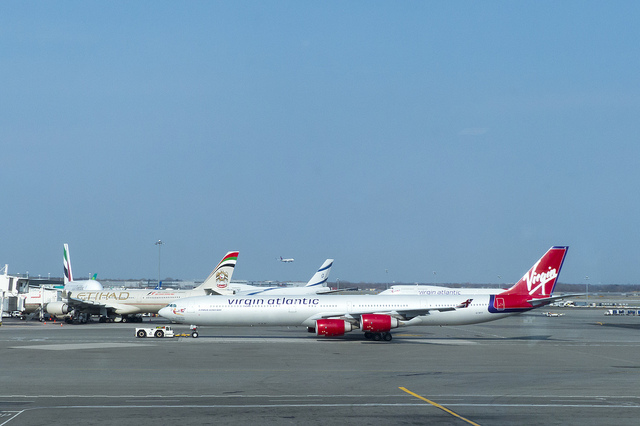Please transcribe the text in this image. virgin atlantic ETIHAD atlantic Virgin 